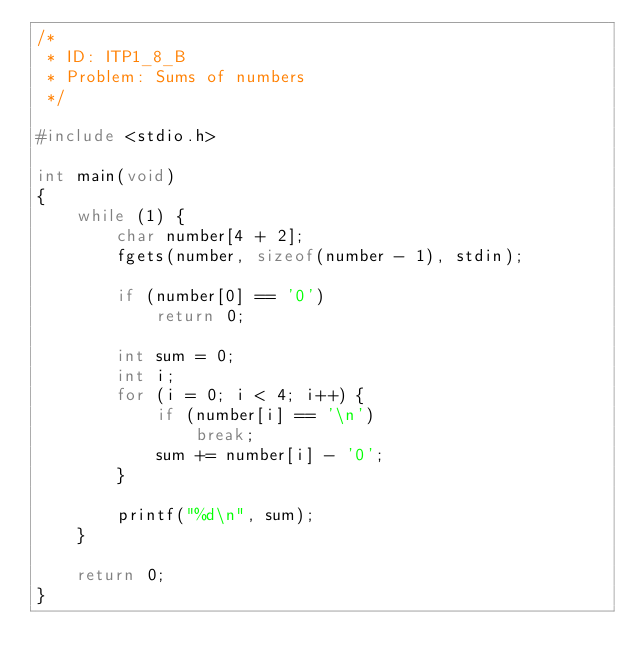Convert code to text. <code><loc_0><loc_0><loc_500><loc_500><_C_>/*
 * ID: ITP1_8_B
 * Problem: Sums of numbers
 */

#include <stdio.h>

int main(void)
{
    while (1) {
        char number[4 + 2];
        fgets(number, sizeof(number - 1), stdin);
        
        if (number[0] == '0')
            return 0;

        int sum = 0;
        int i;
        for (i = 0; i < 4; i++) {
            if (number[i] == '\n')
                break;
            sum += number[i] - '0';
        }

        printf("%d\n", sum);
    }

    return 0;
}


</code> 